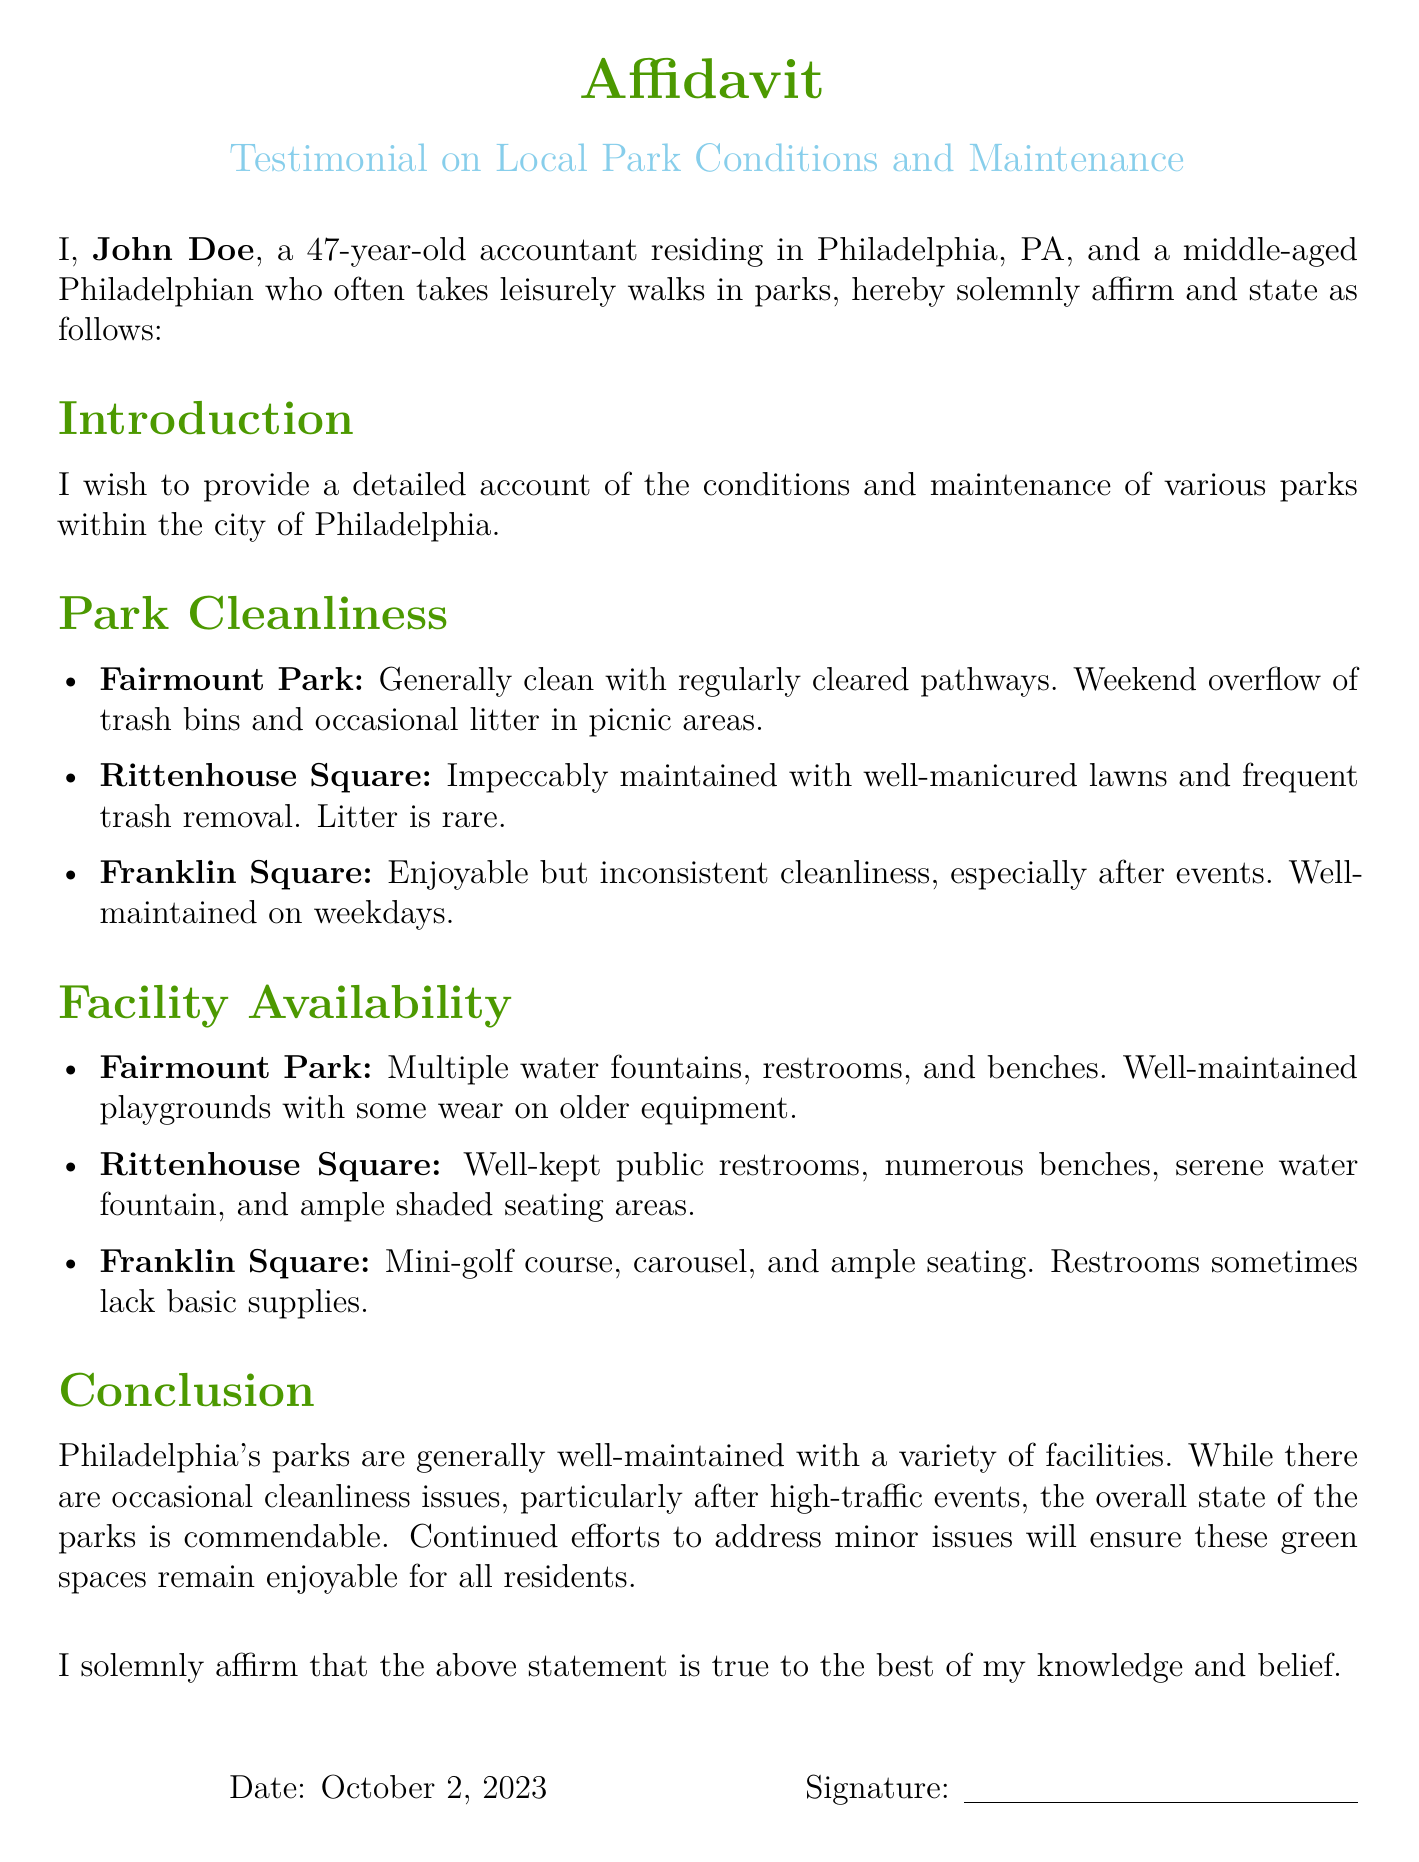What is the name of the affiant? The affiant's name is mentioned at the beginning of the document as John Doe.
Answer: John Doe What is the date of the affidavit? The date is written under the signature section of the document, which is October 2, 2023.
Answer: October 2, 2023 Which park is described as impeccably maintained? The document states that Rittenhouse Square is impeccably maintained with well-manicured lawns.
Answer: Rittenhouse Square How many parks are specifically mentioned in the affidavit? There are three parks detailed in the affidavit: Fairmount Park, Rittenhouse Square, and Franklin Square.
Answer: Three What issue does Fairmount Park face on weekends? The document indicates that Fairmount Park has overflow of trash bins on weekends.
Answer: Overflow of trash bins What facility is sometimes lacking basic supplies at Franklin Square? The document specifies that restrooms at Franklin Square can sometimes lack basic supplies.
Answer: Restrooms Which park has well-kept public restrooms? The document mentions Rittenhouse Square as having well-kept public restrooms.
Answer: Rittenhouse Square What does the affiant affirm at the end of the document? The affiant solemnly affirms that the statement is true to the best of his knowledge and belief.
Answer: True to the best of my knowledge and belief What is the main conclusion about Philadelphia's parks? The conclusion states that Philadelphia's parks are generally well-maintained with some occasional cleanliness issues.
Answer: Generally well-maintained 